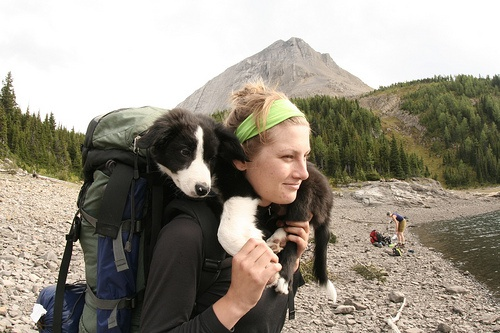Describe the objects in this image and their specific colors. I can see people in white, black, gray, and tan tones, backpack in white, black, and gray tones, dog in white, black, ivory, and gray tones, people in white, gray, tan, and darkgray tones, and backpack in white, black, gray, maroon, and brown tones in this image. 